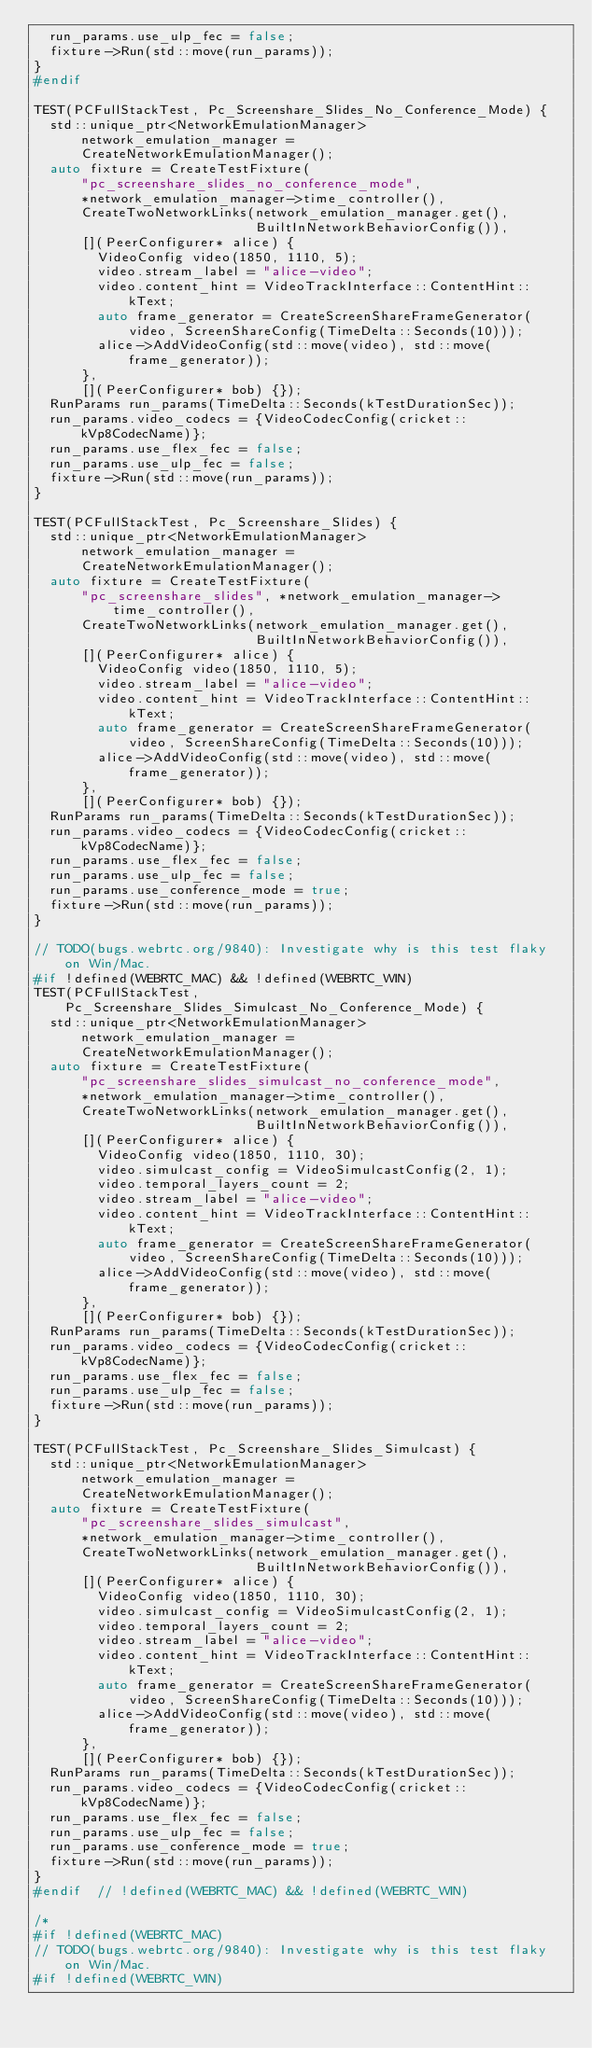Convert code to text. <code><loc_0><loc_0><loc_500><loc_500><_C++_>  run_params.use_ulp_fec = false;
  fixture->Run(std::move(run_params));
}
#endif

TEST(PCFullStackTest, Pc_Screenshare_Slides_No_Conference_Mode) {
  std::unique_ptr<NetworkEmulationManager> network_emulation_manager =
      CreateNetworkEmulationManager();
  auto fixture = CreateTestFixture(
      "pc_screenshare_slides_no_conference_mode",
      *network_emulation_manager->time_controller(),
      CreateTwoNetworkLinks(network_emulation_manager.get(),
                            BuiltInNetworkBehaviorConfig()),
      [](PeerConfigurer* alice) {
        VideoConfig video(1850, 1110, 5);
        video.stream_label = "alice-video";
        video.content_hint = VideoTrackInterface::ContentHint::kText;
        auto frame_generator = CreateScreenShareFrameGenerator(
            video, ScreenShareConfig(TimeDelta::Seconds(10)));
        alice->AddVideoConfig(std::move(video), std::move(frame_generator));
      },
      [](PeerConfigurer* bob) {});
  RunParams run_params(TimeDelta::Seconds(kTestDurationSec));
  run_params.video_codecs = {VideoCodecConfig(cricket::kVp8CodecName)};
  run_params.use_flex_fec = false;
  run_params.use_ulp_fec = false;
  fixture->Run(std::move(run_params));
}

TEST(PCFullStackTest, Pc_Screenshare_Slides) {
  std::unique_ptr<NetworkEmulationManager> network_emulation_manager =
      CreateNetworkEmulationManager();
  auto fixture = CreateTestFixture(
      "pc_screenshare_slides", *network_emulation_manager->time_controller(),
      CreateTwoNetworkLinks(network_emulation_manager.get(),
                            BuiltInNetworkBehaviorConfig()),
      [](PeerConfigurer* alice) {
        VideoConfig video(1850, 1110, 5);
        video.stream_label = "alice-video";
        video.content_hint = VideoTrackInterface::ContentHint::kText;
        auto frame_generator = CreateScreenShareFrameGenerator(
            video, ScreenShareConfig(TimeDelta::Seconds(10)));
        alice->AddVideoConfig(std::move(video), std::move(frame_generator));
      },
      [](PeerConfigurer* bob) {});
  RunParams run_params(TimeDelta::Seconds(kTestDurationSec));
  run_params.video_codecs = {VideoCodecConfig(cricket::kVp8CodecName)};
  run_params.use_flex_fec = false;
  run_params.use_ulp_fec = false;
  run_params.use_conference_mode = true;
  fixture->Run(std::move(run_params));
}

// TODO(bugs.webrtc.org/9840): Investigate why is this test flaky on Win/Mac.
#if !defined(WEBRTC_MAC) && !defined(WEBRTC_WIN)
TEST(PCFullStackTest, Pc_Screenshare_Slides_Simulcast_No_Conference_Mode) {
  std::unique_ptr<NetworkEmulationManager> network_emulation_manager =
      CreateNetworkEmulationManager();
  auto fixture = CreateTestFixture(
      "pc_screenshare_slides_simulcast_no_conference_mode",
      *network_emulation_manager->time_controller(),
      CreateTwoNetworkLinks(network_emulation_manager.get(),
                            BuiltInNetworkBehaviorConfig()),
      [](PeerConfigurer* alice) {
        VideoConfig video(1850, 1110, 30);
        video.simulcast_config = VideoSimulcastConfig(2, 1);
        video.temporal_layers_count = 2;
        video.stream_label = "alice-video";
        video.content_hint = VideoTrackInterface::ContentHint::kText;
        auto frame_generator = CreateScreenShareFrameGenerator(
            video, ScreenShareConfig(TimeDelta::Seconds(10)));
        alice->AddVideoConfig(std::move(video), std::move(frame_generator));
      },
      [](PeerConfigurer* bob) {});
  RunParams run_params(TimeDelta::Seconds(kTestDurationSec));
  run_params.video_codecs = {VideoCodecConfig(cricket::kVp8CodecName)};
  run_params.use_flex_fec = false;
  run_params.use_ulp_fec = false;
  fixture->Run(std::move(run_params));
}

TEST(PCFullStackTest, Pc_Screenshare_Slides_Simulcast) {
  std::unique_ptr<NetworkEmulationManager> network_emulation_manager =
      CreateNetworkEmulationManager();
  auto fixture = CreateTestFixture(
      "pc_screenshare_slides_simulcast",
      *network_emulation_manager->time_controller(),
      CreateTwoNetworkLinks(network_emulation_manager.get(),
                            BuiltInNetworkBehaviorConfig()),
      [](PeerConfigurer* alice) {
        VideoConfig video(1850, 1110, 30);
        video.simulcast_config = VideoSimulcastConfig(2, 1);
        video.temporal_layers_count = 2;
        video.stream_label = "alice-video";
        video.content_hint = VideoTrackInterface::ContentHint::kText;
        auto frame_generator = CreateScreenShareFrameGenerator(
            video, ScreenShareConfig(TimeDelta::Seconds(10)));
        alice->AddVideoConfig(std::move(video), std::move(frame_generator));
      },
      [](PeerConfigurer* bob) {});
  RunParams run_params(TimeDelta::Seconds(kTestDurationSec));
  run_params.video_codecs = {VideoCodecConfig(cricket::kVp8CodecName)};
  run_params.use_flex_fec = false;
  run_params.use_ulp_fec = false;
  run_params.use_conference_mode = true;
  fixture->Run(std::move(run_params));
}
#endif  // !defined(WEBRTC_MAC) && !defined(WEBRTC_WIN)

/*
#if !defined(WEBRTC_MAC)
// TODO(bugs.webrtc.org/9840): Investigate why is this test flaky on Win/Mac.
#if !defined(WEBRTC_WIN)</code> 